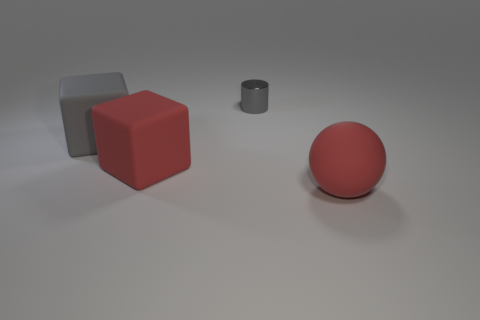There is a cube that is the same color as the metal cylinder; what is it made of?
Keep it short and to the point. Rubber. Do the metallic object and the matte ball have the same color?
Give a very brief answer. No. How many other things are the same material as the large red sphere?
Your response must be concise. 2. What shape is the red rubber object that is behind the red matte thing that is on the right side of the metal object?
Offer a very short reply. Cube. What is the size of the matte ball that is in front of the tiny shiny object?
Offer a terse response. Large. Is the material of the tiny object the same as the large red cube?
Give a very brief answer. No. The big gray thing that is the same material as the big red cube is what shape?
Your answer should be compact. Cube. Is there any other thing of the same color as the small metallic cylinder?
Keep it short and to the point. Yes. The thing that is behind the large gray cube is what color?
Make the answer very short. Gray. Does the large block in front of the gray matte thing have the same color as the metallic cylinder?
Your answer should be compact. No. 